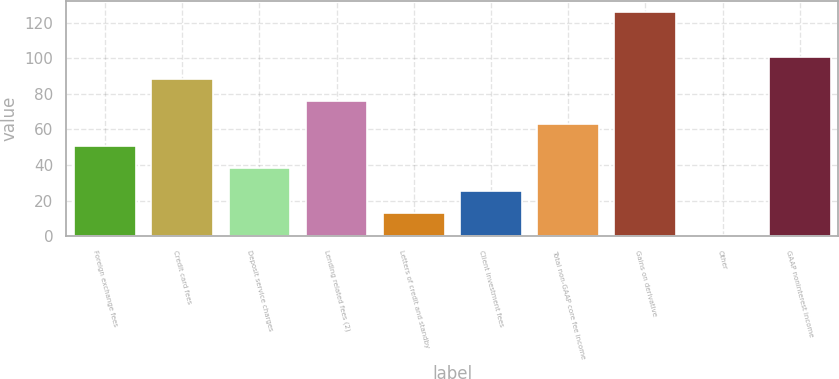Convert chart. <chart><loc_0><loc_0><loc_500><loc_500><bar_chart><fcel>Foreign exchange fees<fcel>Credit card fees<fcel>Deposit service charges<fcel>Lending related fees (2)<fcel>Letters of credit and standby<fcel>Client investment fees<fcel>Total non-GAAP core fee income<fcel>Gains on derivative<fcel>Other<fcel>GAAP noninterest income<nl><fcel>50.68<fcel>88.24<fcel>38.16<fcel>75.72<fcel>13.12<fcel>25.64<fcel>63.2<fcel>125.8<fcel>0.6<fcel>100.76<nl></chart> 